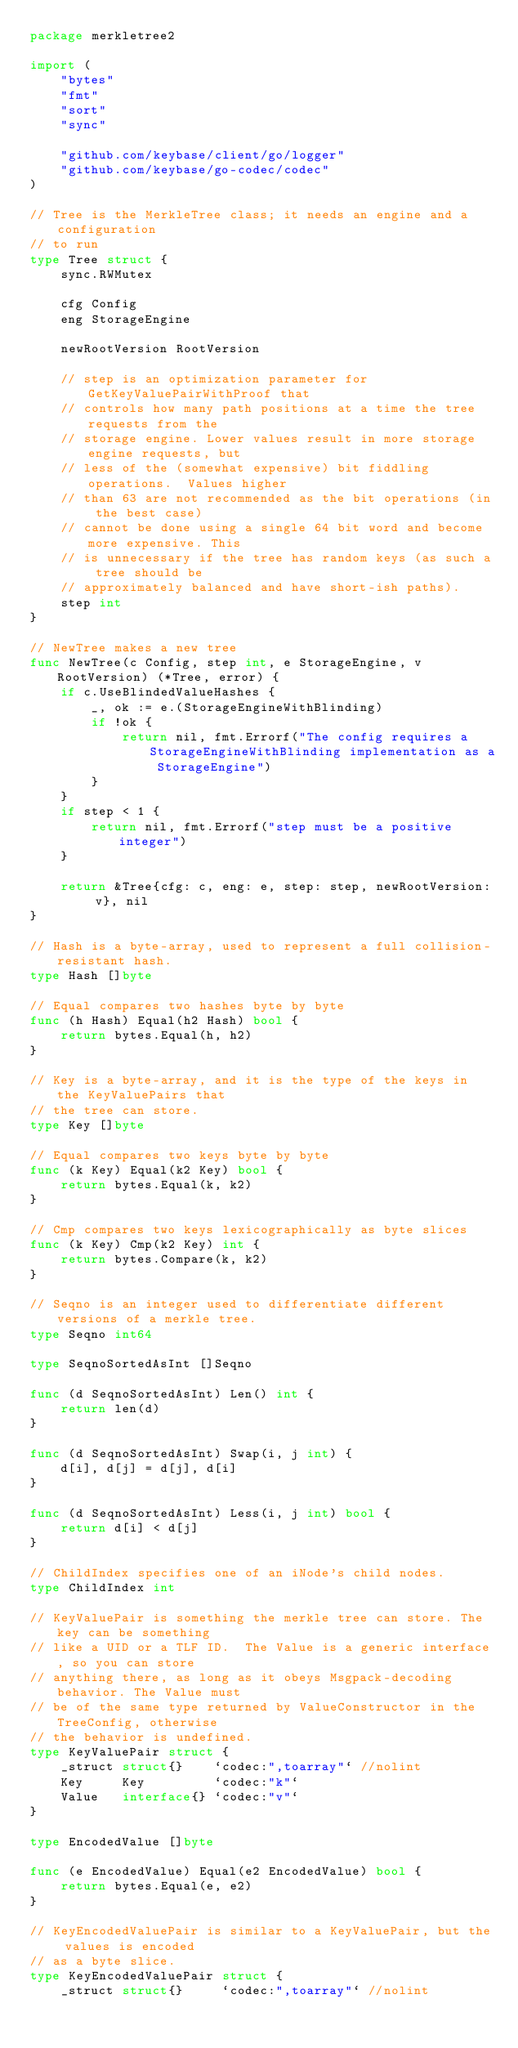<code> <loc_0><loc_0><loc_500><loc_500><_Go_>package merkletree2

import (
	"bytes"
	"fmt"
	"sort"
	"sync"

	"github.com/keybase/client/go/logger"
	"github.com/keybase/go-codec/codec"
)

// Tree is the MerkleTree class; it needs an engine and a configuration
// to run
type Tree struct {
	sync.RWMutex

	cfg Config
	eng StorageEngine

	newRootVersion RootVersion

	// step is an optimization parameter for GetKeyValuePairWithProof that
	// controls how many path positions at a time the tree requests from the
	// storage engine. Lower values result in more storage engine requests, but
	// less of the (somewhat expensive) bit fiddling operations.  Values higher
	// than 63 are not recommended as the bit operations (in the best case)
	// cannot be done using a single 64 bit word and become more expensive. This
	// is unnecessary if the tree has random keys (as such a tree should be
	// approximately balanced and have short-ish paths).
	step int
}

// NewTree makes a new tree
func NewTree(c Config, step int, e StorageEngine, v RootVersion) (*Tree, error) {
	if c.UseBlindedValueHashes {
		_, ok := e.(StorageEngineWithBlinding)
		if !ok {
			return nil, fmt.Errorf("The config requires a StorageEngineWithBlinding implementation as a StorageEngine")
		}
	}
	if step < 1 {
		return nil, fmt.Errorf("step must be a positive integer")
	}

	return &Tree{cfg: c, eng: e, step: step, newRootVersion: v}, nil
}

// Hash is a byte-array, used to represent a full collision-resistant hash.
type Hash []byte

// Equal compares two hashes byte by byte
func (h Hash) Equal(h2 Hash) bool {
	return bytes.Equal(h, h2)
}

// Key is a byte-array, and it is the type of the keys in the KeyValuePairs that
// the tree can store.
type Key []byte

// Equal compares two keys byte by byte
func (k Key) Equal(k2 Key) bool {
	return bytes.Equal(k, k2)
}

// Cmp compares two keys lexicographically as byte slices
func (k Key) Cmp(k2 Key) int {
	return bytes.Compare(k, k2)
}

// Seqno is an integer used to differentiate different versions of a merkle tree.
type Seqno int64

type SeqnoSortedAsInt []Seqno

func (d SeqnoSortedAsInt) Len() int {
	return len(d)
}

func (d SeqnoSortedAsInt) Swap(i, j int) {
	d[i], d[j] = d[j], d[i]
}

func (d SeqnoSortedAsInt) Less(i, j int) bool {
	return d[i] < d[j]
}

// ChildIndex specifies one of an iNode's child nodes.
type ChildIndex int

// KeyValuePair is something the merkle tree can store. The key can be something
// like a UID or a TLF ID.  The Value is a generic interface, so you can store
// anything there, as long as it obeys Msgpack-decoding behavior. The Value must
// be of the same type returned by ValueConstructor in the TreeConfig, otherwise
// the behavior is undefined.
type KeyValuePair struct {
	_struct struct{}    `codec:",toarray"` //nolint
	Key     Key         `codec:"k"`
	Value   interface{} `codec:"v"`
}

type EncodedValue []byte

func (e EncodedValue) Equal(e2 EncodedValue) bool {
	return bytes.Equal(e, e2)
}

// KeyEncodedValuePair is similar to a KeyValuePair, but the values is encoded
// as a byte slice.
type KeyEncodedValuePair struct {
	_struct struct{}     `codec:",toarray"` //nolint</code> 